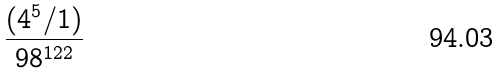<formula> <loc_0><loc_0><loc_500><loc_500>\frac { ( 4 ^ { 5 } / 1 ) } { 9 8 ^ { 1 2 2 } }</formula> 